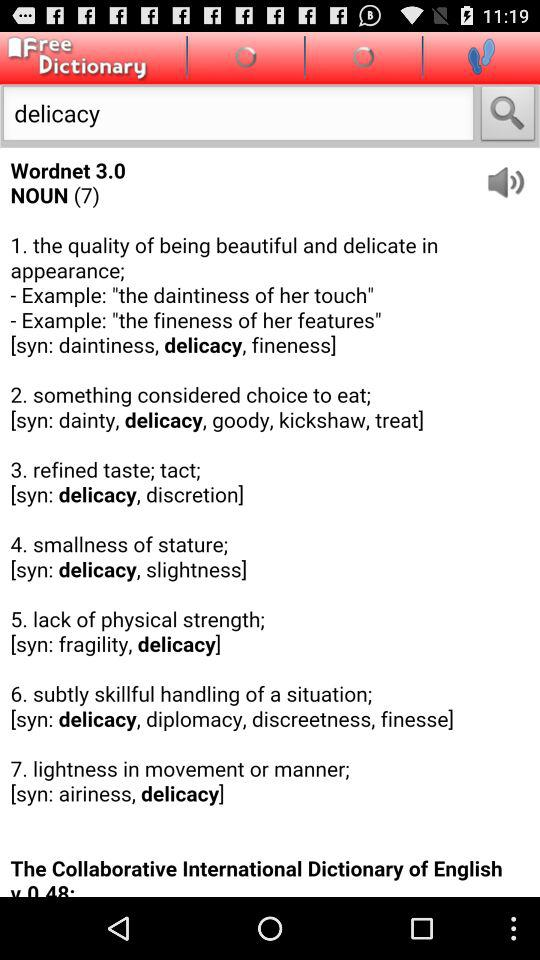How many definitions are there for 'delicacy'?
Answer the question using a single word or phrase. 7 